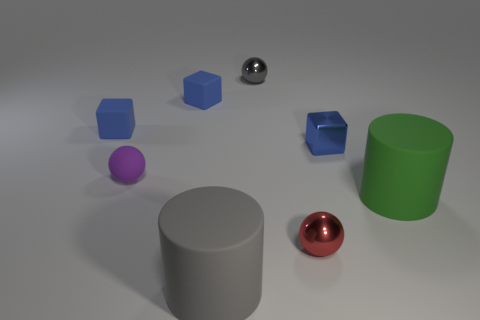Add 2 purple metal cylinders. How many objects exist? 10 Subtract all balls. How many objects are left? 5 Subtract 0 brown blocks. How many objects are left? 8 Subtract all small red cylinders. Subtract all small spheres. How many objects are left? 5 Add 5 large gray things. How many large gray things are left? 6 Add 6 small red objects. How many small red objects exist? 7 